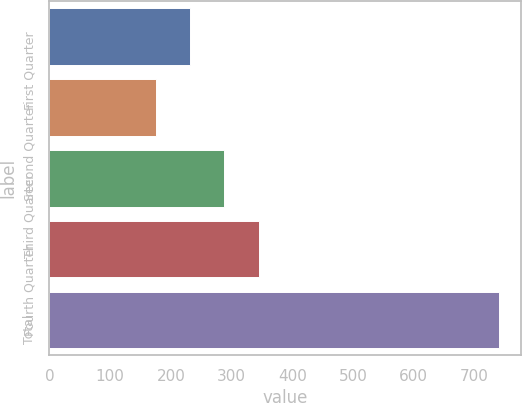<chart> <loc_0><loc_0><loc_500><loc_500><bar_chart><fcel>First Quarter<fcel>Second Quarter<fcel>Third Quarter<fcel>Fourth Quarter<fcel>Total<nl><fcel>231.49<fcel>175<fcel>287.98<fcel>344.47<fcel>739.9<nl></chart> 